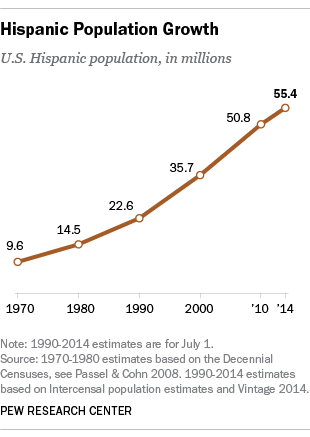Draw attention to some important aspects in this diagram. The U.S. Hispanic population was below 30 million for a period of three years. In 2000, the Hispanic population in the United States was approximately 35.7 million people. 